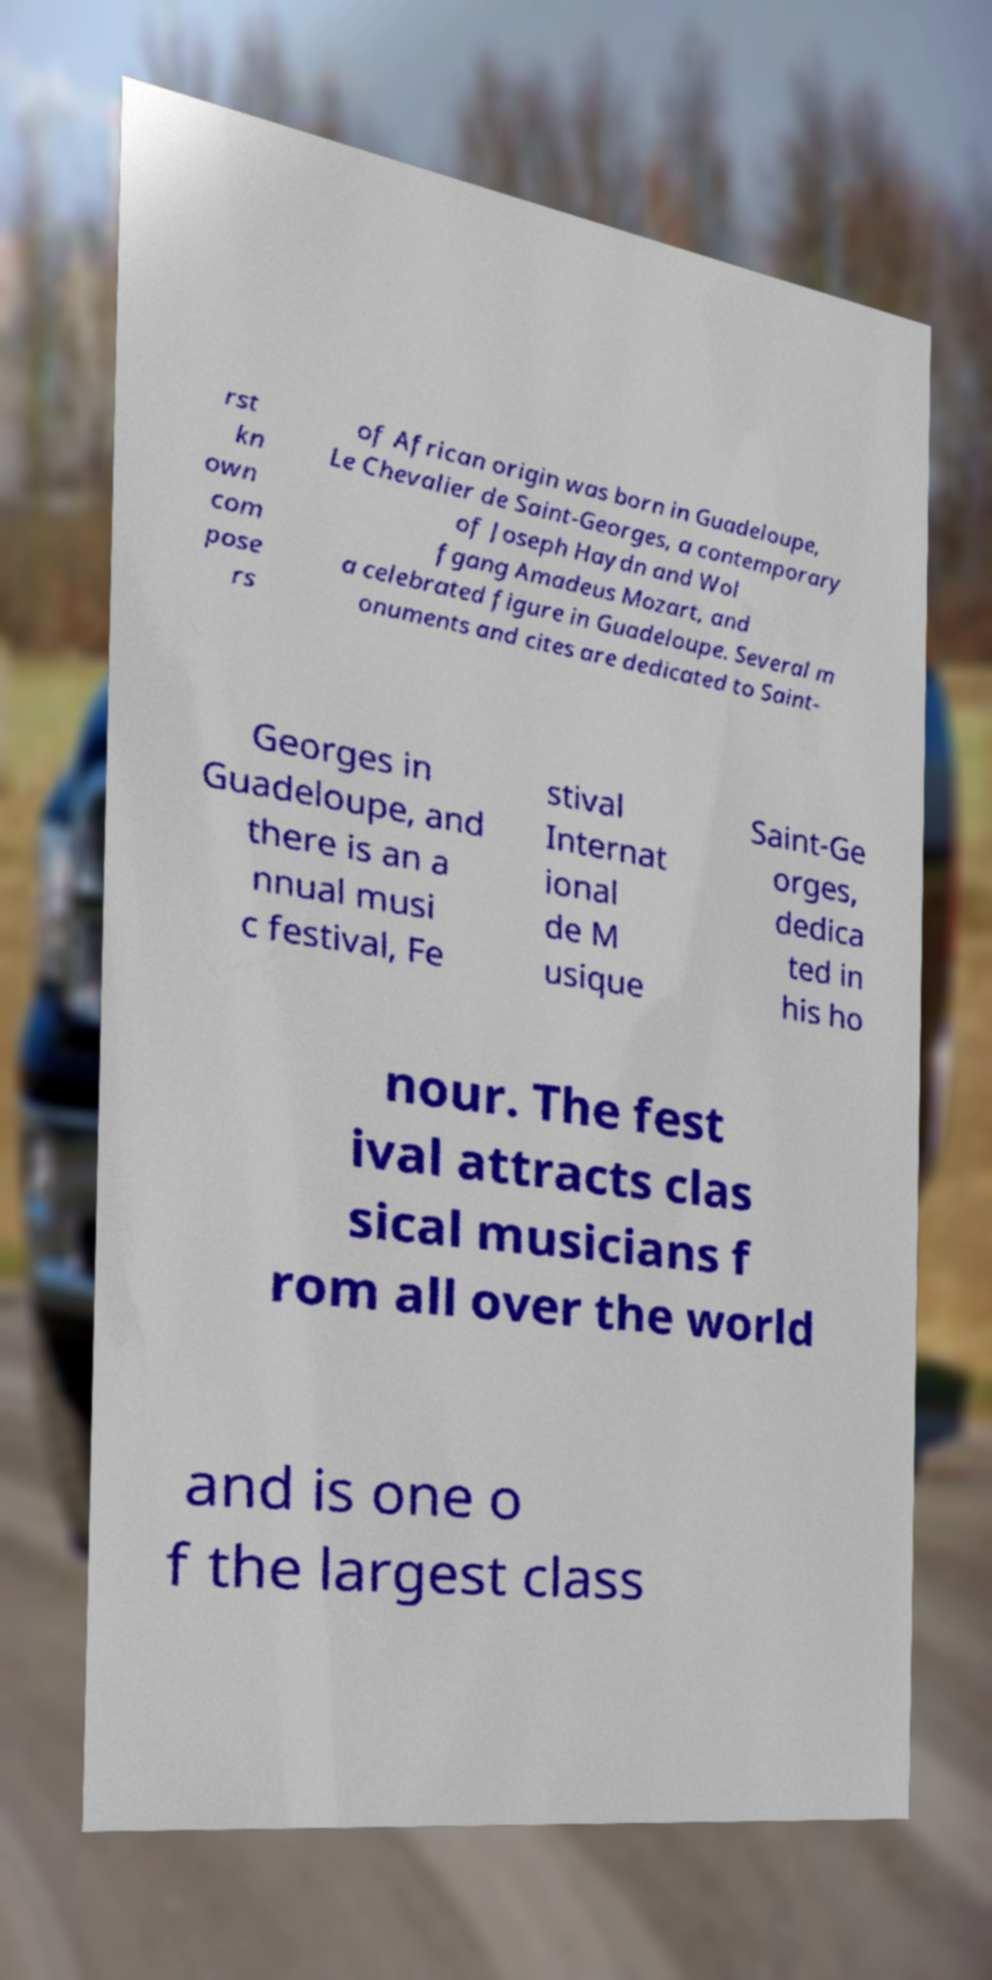Please identify and transcribe the text found in this image. rst kn own com pose rs of African origin was born in Guadeloupe, Le Chevalier de Saint-Georges, a contemporary of Joseph Haydn and Wol fgang Amadeus Mozart, and a celebrated figure in Guadeloupe. Several m onuments and cites are dedicated to Saint- Georges in Guadeloupe, and there is an a nnual musi c festival, Fe stival Internat ional de M usique Saint-Ge orges, dedica ted in his ho nour. The fest ival attracts clas sical musicians f rom all over the world and is one o f the largest class 